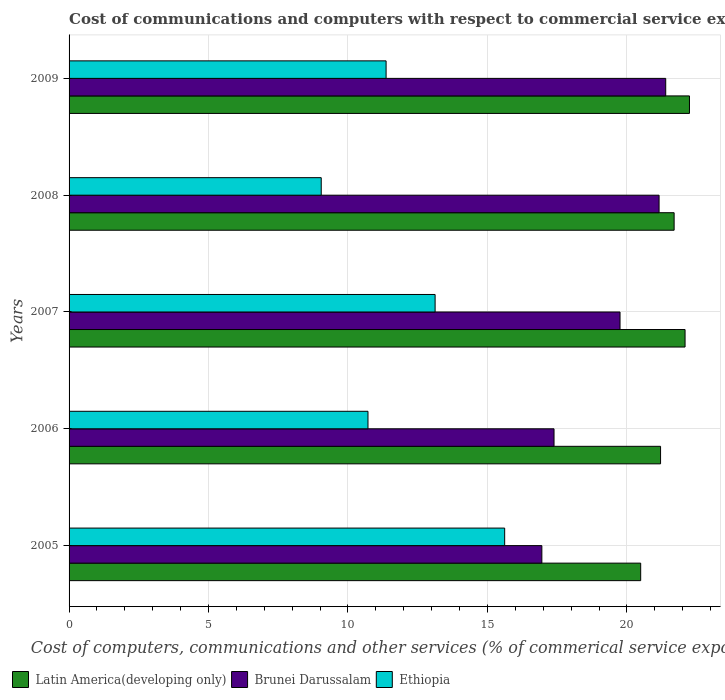How many different coloured bars are there?
Keep it short and to the point. 3. Are the number of bars per tick equal to the number of legend labels?
Offer a very short reply. Yes. How many bars are there on the 2nd tick from the bottom?
Offer a terse response. 3. What is the label of the 2nd group of bars from the top?
Give a very brief answer. 2008. In how many cases, is the number of bars for a given year not equal to the number of legend labels?
Offer a terse response. 0. What is the cost of communications and computers in Brunei Darussalam in 2005?
Keep it short and to the point. 16.95. Across all years, what is the maximum cost of communications and computers in Ethiopia?
Keep it short and to the point. 15.62. Across all years, what is the minimum cost of communications and computers in Ethiopia?
Provide a succinct answer. 9.04. In which year was the cost of communications and computers in Brunei Darussalam minimum?
Your response must be concise. 2005. What is the total cost of communications and computers in Ethiopia in the graph?
Your answer should be very brief. 59.86. What is the difference between the cost of communications and computers in Ethiopia in 2007 and that in 2009?
Give a very brief answer. 1.76. What is the difference between the cost of communications and computers in Brunei Darussalam in 2009 and the cost of communications and computers in Ethiopia in 2008?
Provide a succinct answer. 12.35. What is the average cost of communications and computers in Brunei Darussalam per year?
Provide a short and direct response. 19.33. In the year 2006, what is the difference between the cost of communications and computers in Latin America(developing only) and cost of communications and computers in Ethiopia?
Offer a very short reply. 10.49. In how many years, is the cost of communications and computers in Brunei Darussalam greater than 19 %?
Give a very brief answer. 3. What is the ratio of the cost of communications and computers in Latin America(developing only) in 2006 to that in 2008?
Your response must be concise. 0.98. Is the cost of communications and computers in Latin America(developing only) in 2006 less than that in 2008?
Your response must be concise. Yes. What is the difference between the highest and the second highest cost of communications and computers in Ethiopia?
Your answer should be compact. 2.49. What is the difference between the highest and the lowest cost of communications and computers in Latin America(developing only)?
Make the answer very short. 1.75. What does the 2nd bar from the top in 2008 represents?
Offer a very short reply. Brunei Darussalam. What does the 1st bar from the bottom in 2006 represents?
Offer a terse response. Latin America(developing only). How many years are there in the graph?
Your answer should be very brief. 5. Does the graph contain grids?
Offer a terse response. Yes. Where does the legend appear in the graph?
Ensure brevity in your answer.  Bottom left. How many legend labels are there?
Give a very brief answer. 3. How are the legend labels stacked?
Provide a succinct answer. Horizontal. What is the title of the graph?
Make the answer very short. Cost of communications and computers with respect to commercial service exports. Does "Congo (Democratic)" appear as one of the legend labels in the graph?
Provide a short and direct response. No. What is the label or title of the X-axis?
Make the answer very short. Cost of computers, communications and other services (% of commerical service exports). What is the label or title of the Y-axis?
Offer a very short reply. Years. What is the Cost of computers, communications and other services (% of commerical service exports) in Latin America(developing only) in 2005?
Keep it short and to the point. 20.49. What is the Cost of computers, communications and other services (% of commerical service exports) in Brunei Darussalam in 2005?
Make the answer very short. 16.95. What is the Cost of computers, communications and other services (% of commerical service exports) of Ethiopia in 2005?
Your response must be concise. 15.62. What is the Cost of computers, communications and other services (% of commerical service exports) in Latin America(developing only) in 2006?
Make the answer very short. 21.21. What is the Cost of computers, communications and other services (% of commerical service exports) in Brunei Darussalam in 2006?
Keep it short and to the point. 17.39. What is the Cost of computers, communications and other services (% of commerical service exports) of Ethiopia in 2006?
Keep it short and to the point. 10.72. What is the Cost of computers, communications and other services (% of commerical service exports) of Latin America(developing only) in 2007?
Your answer should be very brief. 22.09. What is the Cost of computers, communications and other services (% of commerical service exports) in Brunei Darussalam in 2007?
Provide a short and direct response. 19.75. What is the Cost of computers, communications and other services (% of commerical service exports) of Ethiopia in 2007?
Offer a terse response. 13.12. What is the Cost of computers, communications and other services (% of commerical service exports) in Latin America(developing only) in 2008?
Provide a succinct answer. 21.69. What is the Cost of computers, communications and other services (% of commerical service exports) in Brunei Darussalam in 2008?
Your response must be concise. 21.15. What is the Cost of computers, communications and other services (% of commerical service exports) of Ethiopia in 2008?
Your answer should be very brief. 9.04. What is the Cost of computers, communications and other services (% of commerical service exports) in Latin America(developing only) in 2009?
Give a very brief answer. 22.24. What is the Cost of computers, communications and other services (% of commerical service exports) in Brunei Darussalam in 2009?
Offer a terse response. 21.39. What is the Cost of computers, communications and other services (% of commerical service exports) in Ethiopia in 2009?
Your answer should be very brief. 11.37. Across all years, what is the maximum Cost of computers, communications and other services (% of commerical service exports) in Latin America(developing only)?
Ensure brevity in your answer.  22.24. Across all years, what is the maximum Cost of computers, communications and other services (% of commerical service exports) in Brunei Darussalam?
Your answer should be compact. 21.39. Across all years, what is the maximum Cost of computers, communications and other services (% of commerical service exports) in Ethiopia?
Make the answer very short. 15.62. Across all years, what is the minimum Cost of computers, communications and other services (% of commerical service exports) in Latin America(developing only)?
Ensure brevity in your answer.  20.49. Across all years, what is the minimum Cost of computers, communications and other services (% of commerical service exports) of Brunei Darussalam?
Give a very brief answer. 16.95. Across all years, what is the minimum Cost of computers, communications and other services (% of commerical service exports) in Ethiopia?
Provide a succinct answer. 9.04. What is the total Cost of computers, communications and other services (% of commerical service exports) of Latin America(developing only) in the graph?
Keep it short and to the point. 107.72. What is the total Cost of computers, communications and other services (% of commerical service exports) of Brunei Darussalam in the graph?
Your answer should be very brief. 96.64. What is the total Cost of computers, communications and other services (% of commerical service exports) of Ethiopia in the graph?
Keep it short and to the point. 59.86. What is the difference between the Cost of computers, communications and other services (% of commerical service exports) in Latin America(developing only) in 2005 and that in 2006?
Offer a terse response. -0.71. What is the difference between the Cost of computers, communications and other services (% of commerical service exports) of Brunei Darussalam in 2005 and that in 2006?
Make the answer very short. -0.44. What is the difference between the Cost of computers, communications and other services (% of commerical service exports) in Ethiopia in 2005 and that in 2006?
Your answer should be very brief. 4.9. What is the difference between the Cost of computers, communications and other services (% of commerical service exports) in Latin America(developing only) in 2005 and that in 2007?
Provide a succinct answer. -1.59. What is the difference between the Cost of computers, communications and other services (% of commerical service exports) in Brunei Darussalam in 2005 and that in 2007?
Make the answer very short. -2.8. What is the difference between the Cost of computers, communications and other services (% of commerical service exports) of Ethiopia in 2005 and that in 2007?
Your answer should be compact. 2.49. What is the difference between the Cost of computers, communications and other services (% of commerical service exports) of Latin America(developing only) in 2005 and that in 2008?
Ensure brevity in your answer.  -1.2. What is the difference between the Cost of computers, communications and other services (% of commerical service exports) of Brunei Darussalam in 2005 and that in 2008?
Offer a terse response. -4.2. What is the difference between the Cost of computers, communications and other services (% of commerical service exports) of Ethiopia in 2005 and that in 2008?
Give a very brief answer. 6.58. What is the difference between the Cost of computers, communications and other services (% of commerical service exports) of Latin America(developing only) in 2005 and that in 2009?
Make the answer very short. -1.75. What is the difference between the Cost of computers, communications and other services (% of commerical service exports) of Brunei Darussalam in 2005 and that in 2009?
Ensure brevity in your answer.  -4.44. What is the difference between the Cost of computers, communications and other services (% of commerical service exports) of Ethiopia in 2005 and that in 2009?
Your answer should be very brief. 4.25. What is the difference between the Cost of computers, communications and other services (% of commerical service exports) of Latin America(developing only) in 2006 and that in 2007?
Make the answer very short. -0.88. What is the difference between the Cost of computers, communications and other services (% of commerical service exports) in Brunei Darussalam in 2006 and that in 2007?
Your answer should be very brief. -2.37. What is the difference between the Cost of computers, communications and other services (% of commerical service exports) in Ethiopia in 2006 and that in 2007?
Ensure brevity in your answer.  -2.41. What is the difference between the Cost of computers, communications and other services (% of commerical service exports) of Latin America(developing only) in 2006 and that in 2008?
Your answer should be compact. -0.49. What is the difference between the Cost of computers, communications and other services (% of commerical service exports) in Brunei Darussalam in 2006 and that in 2008?
Your answer should be very brief. -3.77. What is the difference between the Cost of computers, communications and other services (% of commerical service exports) of Ethiopia in 2006 and that in 2008?
Your answer should be very brief. 1.68. What is the difference between the Cost of computers, communications and other services (% of commerical service exports) of Latin America(developing only) in 2006 and that in 2009?
Your response must be concise. -1.04. What is the difference between the Cost of computers, communications and other services (% of commerical service exports) of Brunei Darussalam in 2006 and that in 2009?
Provide a succinct answer. -4. What is the difference between the Cost of computers, communications and other services (% of commerical service exports) of Ethiopia in 2006 and that in 2009?
Your response must be concise. -0.65. What is the difference between the Cost of computers, communications and other services (% of commerical service exports) of Latin America(developing only) in 2007 and that in 2008?
Make the answer very short. 0.39. What is the difference between the Cost of computers, communications and other services (% of commerical service exports) of Brunei Darussalam in 2007 and that in 2008?
Provide a succinct answer. -1.4. What is the difference between the Cost of computers, communications and other services (% of commerical service exports) in Ethiopia in 2007 and that in 2008?
Keep it short and to the point. 4.08. What is the difference between the Cost of computers, communications and other services (% of commerical service exports) of Latin America(developing only) in 2007 and that in 2009?
Your answer should be compact. -0.16. What is the difference between the Cost of computers, communications and other services (% of commerical service exports) of Brunei Darussalam in 2007 and that in 2009?
Give a very brief answer. -1.64. What is the difference between the Cost of computers, communications and other services (% of commerical service exports) of Ethiopia in 2007 and that in 2009?
Offer a terse response. 1.76. What is the difference between the Cost of computers, communications and other services (% of commerical service exports) in Latin America(developing only) in 2008 and that in 2009?
Offer a very short reply. -0.55. What is the difference between the Cost of computers, communications and other services (% of commerical service exports) in Brunei Darussalam in 2008 and that in 2009?
Your answer should be very brief. -0.24. What is the difference between the Cost of computers, communications and other services (% of commerical service exports) of Ethiopia in 2008 and that in 2009?
Provide a short and direct response. -2.33. What is the difference between the Cost of computers, communications and other services (% of commerical service exports) of Latin America(developing only) in 2005 and the Cost of computers, communications and other services (% of commerical service exports) of Brunei Darussalam in 2006?
Make the answer very short. 3.11. What is the difference between the Cost of computers, communications and other services (% of commerical service exports) in Latin America(developing only) in 2005 and the Cost of computers, communications and other services (% of commerical service exports) in Ethiopia in 2006?
Your answer should be very brief. 9.78. What is the difference between the Cost of computers, communications and other services (% of commerical service exports) of Brunei Darussalam in 2005 and the Cost of computers, communications and other services (% of commerical service exports) of Ethiopia in 2006?
Your answer should be very brief. 6.23. What is the difference between the Cost of computers, communications and other services (% of commerical service exports) of Latin America(developing only) in 2005 and the Cost of computers, communications and other services (% of commerical service exports) of Brunei Darussalam in 2007?
Your answer should be compact. 0.74. What is the difference between the Cost of computers, communications and other services (% of commerical service exports) of Latin America(developing only) in 2005 and the Cost of computers, communications and other services (% of commerical service exports) of Ethiopia in 2007?
Provide a succinct answer. 7.37. What is the difference between the Cost of computers, communications and other services (% of commerical service exports) in Brunei Darussalam in 2005 and the Cost of computers, communications and other services (% of commerical service exports) in Ethiopia in 2007?
Provide a short and direct response. 3.83. What is the difference between the Cost of computers, communications and other services (% of commerical service exports) of Latin America(developing only) in 2005 and the Cost of computers, communications and other services (% of commerical service exports) of Brunei Darussalam in 2008?
Your answer should be compact. -0.66. What is the difference between the Cost of computers, communications and other services (% of commerical service exports) of Latin America(developing only) in 2005 and the Cost of computers, communications and other services (% of commerical service exports) of Ethiopia in 2008?
Ensure brevity in your answer.  11.45. What is the difference between the Cost of computers, communications and other services (% of commerical service exports) of Brunei Darussalam in 2005 and the Cost of computers, communications and other services (% of commerical service exports) of Ethiopia in 2008?
Give a very brief answer. 7.91. What is the difference between the Cost of computers, communications and other services (% of commerical service exports) of Latin America(developing only) in 2005 and the Cost of computers, communications and other services (% of commerical service exports) of Brunei Darussalam in 2009?
Provide a short and direct response. -0.9. What is the difference between the Cost of computers, communications and other services (% of commerical service exports) in Latin America(developing only) in 2005 and the Cost of computers, communications and other services (% of commerical service exports) in Ethiopia in 2009?
Give a very brief answer. 9.13. What is the difference between the Cost of computers, communications and other services (% of commerical service exports) in Brunei Darussalam in 2005 and the Cost of computers, communications and other services (% of commerical service exports) in Ethiopia in 2009?
Keep it short and to the point. 5.58. What is the difference between the Cost of computers, communications and other services (% of commerical service exports) in Latin America(developing only) in 2006 and the Cost of computers, communications and other services (% of commerical service exports) in Brunei Darussalam in 2007?
Your answer should be very brief. 1.45. What is the difference between the Cost of computers, communications and other services (% of commerical service exports) of Latin America(developing only) in 2006 and the Cost of computers, communications and other services (% of commerical service exports) of Ethiopia in 2007?
Your answer should be very brief. 8.08. What is the difference between the Cost of computers, communications and other services (% of commerical service exports) in Brunei Darussalam in 2006 and the Cost of computers, communications and other services (% of commerical service exports) in Ethiopia in 2007?
Ensure brevity in your answer.  4.26. What is the difference between the Cost of computers, communications and other services (% of commerical service exports) of Latin America(developing only) in 2006 and the Cost of computers, communications and other services (% of commerical service exports) of Brunei Darussalam in 2008?
Give a very brief answer. 0.05. What is the difference between the Cost of computers, communications and other services (% of commerical service exports) of Latin America(developing only) in 2006 and the Cost of computers, communications and other services (% of commerical service exports) of Ethiopia in 2008?
Give a very brief answer. 12.17. What is the difference between the Cost of computers, communications and other services (% of commerical service exports) in Brunei Darussalam in 2006 and the Cost of computers, communications and other services (% of commerical service exports) in Ethiopia in 2008?
Make the answer very short. 8.35. What is the difference between the Cost of computers, communications and other services (% of commerical service exports) in Latin America(developing only) in 2006 and the Cost of computers, communications and other services (% of commerical service exports) in Brunei Darussalam in 2009?
Make the answer very short. -0.18. What is the difference between the Cost of computers, communications and other services (% of commerical service exports) in Latin America(developing only) in 2006 and the Cost of computers, communications and other services (% of commerical service exports) in Ethiopia in 2009?
Your answer should be very brief. 9.84. What is the difference between the Cost of computers, communications and other services (% of commerical service exports) in Brunei Darussalam in 2006 and the Cost of computers, communications and other services (% of commerical service exports) in Ethiopia in 2009?
Your response must be concise. 6.02. What is the difference between the Cost of computers, communications and other services (% of commerical service exports) in Latin America(developing only) in 2007 and the Cost of computers, communications and other services (% of commerical service exports) in Brunei Darussalam in 2008?
Give a very brief answer. 0.93. What is the difference between the Cost of computers, communications and other services (% of commerical service exports) of Latin America(developing only) in 2007 and the Cost of computers, communications and other services (% of commerical service exports) of Ethiopia in 2008?
Ensure brevity in your answer.  13.04. What is the difference between the Cost of computers, communications and other services (% of commerical service exports) of Brunei Darussalam in 2007 and the Cost of computers, communications and other services (% of commerical service exports) of Ethiopia in 2008?
Your answer should be very brief. 10.71. What is the difference between the Cost of computers, communications and other services (% of commerical service exports) of Latin America(developing only) in 2007 and the Cost of computers, communications and other services (% of commerical service exports) of Brunei Darussalam in 2009?
Keep it short and to the point. 0.69. What is the difference between the Cost of computers, communications and other services (% of commerical service exports) of Latin America(developing only) in 2007 and the Cost of computers, communications and other services (% of commerical service exports) of Ethiopia in 2009?
Your response must be concise. 10.72. What is the difference between the Cost of computers, communications and other services (% of commerical service exports) in Brunei Darussalam in 2007 and the Cost of computers, communications and other services (% of commerical service exports) in Ethiopia in 2009?
Your answer should be compact. 8.39. What is the difference between the Cost of computers, communications and other services (% of commerical service exports) of Latin America(developing only) in 2008 and the Cost of computers, communications and other services (% of commerical service exports) of Brunei Darussalam in 2009?
Offer a terse response. 0.3. What is the difference between the Cost of computers, communications and other services (% of commerical service exports) in Latin America(developing only) in 2008 and the Cost of computers, communications and other services (% of commerical service exports) in Ethiopia in 2009?
Make the answer very short. 10.33. What is the difference between the Cost of computers, communications and other services (% of commerical service exports) in Brunei Darussalam in 2008 and the Cost of computers, communications and other services (% of commerical service exports) in Ethiopia in 2009?
Provide a succinct answer. 9.79. What is the average Cost of computers, communications and other services (% of commerical service exports) of Latin America(developing only) per year?
Provide a short and direct response. 21.54. What is the average Cost of computers, communications and other services (% of commerical service exports) in Brunei Darussalam per year?
Provide a short and direct response. 19.33. What is the average Cost of computers, communications and other services (% of commerical service exports) of Ethiopia per year?
Make the answer very short. 11.97. In the year 2005, what is the difference between the Cost of computers, communications and other services (% of commerical service exports) in Latin America(developing only) and Cost of computers, communications and other services (% of commerical service exports) in Brunei Darussalam?
Your answer should be very brief. 3.54. In the year 2005, what is the difference between the Cost of computers, communications and other services (% of commerical service exports) of Latin America(developing only) and Cost of computers, communications and other services (% of commerical service exports) of Ethiopia?
Keep it short and to the point. 4.88. In the year 2006, what is the difference between the Cost of computers, communications and other services (% of commerical service exports) in Latin America(developing only) and Cost of computers, communications and other services (% of commerical service exports) in Brunei Darussalam?
Provide a short and direct response. 3.82. In the year 2006, what is the difference between the Cost of computers, communications and other services (% of commerical service exports) in Latin America(developing only) and Cost of computers, communications and other services (% of commerical service exports) in Ethiopia?
Provide a succinct answer. 10.49. In the year 2006, what is the difference between the Cost of computers, communications and other services (% of commerical service exports) in Brunei Darussalam and Cost of computers, communications and other services (% of commerical service exports) in Ethiopia?
Keep it short and to the point. 6.67. In the year 2007, what is the difference between the Cost of computers, communications and other services (% of commerical service exports) of Latin America(developing only) and Cost of computers, communications and other services (% of commerical service exports) of Brunei Darussalam?
Your answer should be compact. 2.33. In the year 2007, what is the difference between the Cost of computers, communications and other services (% of commerical service exports) in Latin America(developing only) and Cost of computers, communications and other services (% of commerical service exports) in Ethiopia?
Give a very brief answer. 8.96. In the year 2007, what is the difference between the Cost of computers, communications and other services (% of commerical service exports) in Brunei Darussalam and Cost of computers, communications and other services (% of commerical service exports) in Ethiopia?
Your answer should be compact. 6.63. In the year 2008, what is the difference between the Cost of computers, communications and other services (% of commerical service exports) of Latin America(developing only) and Cost of computers, communications and other services (% of commerical service exports) of Brunei Darussalam?
Give a very brief answer. 0.54. In the year 2008, what is the difference between the Cost of computers, communications and other services (% of commerical service exports) of Latin America(developing only) and Cost of computers, communications and other services (% of commerical service exports) of Ethiopia?
Offer a terse response. 12.65. In the year 2008, what is the difference between the Cost of computers, communications and other services (% of commerical service exports) in Brunei Darussalam and Cost of computers, communications and other services (% of commerical service exports) in Ethiopia?
Offer a very short reply. 12.11. In the year 2009, what is the difference between the Cost of computers, communications and other services (% of commerical service exports) of Latin America(developing only) and Cost of computers, communications and other services (% of commerical service exports) of Brunei Darussalam?
Ensure brevity in your answer.  0.85. In the year 2009, what is the difference between the Cost of computers, communications and other services (% of commerical service exports) of Latin America(developing only) and Cost of computers, communications and other services (% of commerical service exports) of Ethiopia?
Offer a very short reply. 10.88. In the year 2009, what is the difference between the Cost of computers, communications and other services (% of commerical service exports) in Brunei Darussalam and Cost of computers, communications and other services (% of commerical service exports) in Ethiopia?
Your answer should be very brief. 10.03. What is the ratio of the Cost of computers, communications and other services (% of commerical service exports) of Latin America(developing only) in 2005 to that in 2006?
Make the answer very short. 0.97. What is the ratio of the Cost of computers, communications and other services (% of commerical service exports) in Brunei Darussalam in 2005 to that in 2006?
Give a very brief answer. 0.97. What is the ratio of the Cost of computers, communications and other services (% of commerical service exports) of Ethiopia in 2005 to that in 2006?
Keep it short and to the point. 1.46. What is the ratio of the Cost of computers, communications and other services (% of commerical service exports) of Latin America(developing only) in 2005 to that in 2007?
Your answer should be compact. 0.93. What is the ratio of the Cost of computers, communications and other services (% of commerical service exports) of Brunei Darussalam in 2005 to that in 2007?
Keep it short and to the point. 0.86. What is the ratio of the Cost of computers, communications and other services (% of commerical service exports) of Ethiopia in 2005 to that in 2007?
Keep it short and to the point. 1.19. What is the ratio of the Cost of computers, communications and other services (% of commerical service exports) in Latin America(developing only) in 2005 to that in 2008?
Give a very brief answer. 0.94. What is the ratio of the Cost of computers, communications and other services (% of commerical service exports) of Brunei Darussalam in 2005 to that in 2008?
Your answer should be compact. 0.8. What is the ratio of the Cost of computers, communications and other services (% of commerical service exports) in Ethiopia in 2005 to that in 2008?
Provide a succinct answer. 1.73. What is the ratio of the Cost of computers, communications and other services (% of commerical service exports) of Latin America(developing only) in 2005 to that in 2009?
Ensure brevity in your answer.  0.92. What is the ratio of the Cost of computers, communications and other services (% of commerical service exports) in Brunei Darussalam in 2005 to that in 2009?
Offer a very short reply. 0.79. What is the ratio of the Cost of computers, communications and other services (% of commerical service exports) of Ethiopia in 2005 to that in 2009?
Ensure brevity in your answer.  1.37. What is the ratio of the Cost of computers, communications and other services (% of commerical service exports) in Latin America(developing only) in 2006 to that in 2007?
Make the answer very short. 0.96. What is the ratio of the Cost of computers, communications and other services (% of commerical service exports) of Brunei Darussalam in 2006 to that in 2007?
Offer a very short reply. 0.88. What is the ratio of the Cost of computers, communications and other services (% of commerical service exports) in Ethiopia in 2006 to that in 2007?
Provide a short and direct response. 0.82. What is the ratio of the Cost of computers, communications and other services (% of commerical service exports) of Latin America(developing only) in 2006 to that in 2008?
Your answer should be compact. 0.98. What is the ratio of the Cost of computers, communications and other services (% of commerical service exports) in Brunei Darussalam in 2006 to that in 2008?
Your response must be concise. 0.82. What is the ratio of the Cost of computers, communications and other services (% of commerical service exports) in Ethiopia in 2006 to that in 2008?
Provide a short and direct response. 1.19. What is the ratio of the Cost of computers, communications and other services (% of commerical service exports) of Latin America(developing only) in 2006 to that in 2009?
Your answer should be very brief. 0.95. What is the ratio of the Cost of computers, communications and other services (% of commerical service exports) in Brunei Darussalam in 2006 to that in 2009?
Provide a succinct answer. 0.81. What is the ratio of the Cost of computers, communications and other services (% of commerical service exports) in Ethiopia in 2006 to that in 2009?
Give a very brief answer. 0.94. What is the ratio of the Cost of computers, communications and other services (% of commerical service exports) of Latin America(developing only) in 2007 to that in 2008?
Offer a terse response. 1.02. What is the ratio of the Cost of computers, communications and other services (% of commerical service exports) in Brunei Darussalam in 2007 to that in 2008?
Give a very brief answer. 0.93. What is the ratio of the Cost of computers, communications and other services (% of commerical service exports) in Ethiopia in 2007 to that in 2008?
Your answer should be very brief. 1.45. What is the ratio of the Cost of computers, communications and other services (% of commerical service exports) of Latin America(developing only) in 2007 to that in 2009?
Provide a short and direct response. 0.99. What is the ratio of the Cost of computers, communications and other services (% of commerical service exports) of Brunei Darussalam in 2007 to that in 2009?
Provide a succinct answer. 0.92. What is the ratio of the Cost of computers, communications and other services (% of commerical service exports) of Ethiopia in 2007 to that in 2009?
Your response must be concise. 1.15. What is the ratio of the Cost of computers, communications and other services (% of commerical service exports) in Latin America(developing only) in 2008 to that in 2009?
Make the answer very short. 0.98. What is the ratio of the Cost of computers, communications and other services (% of commerical service exports) of Brunei Darussalam in 2008 to that in 2009?
Offer a terse response. 0.99. What is the ratio of the Cost of computers, communications and other services (% of commerical service exports) of Ethiopia in 2008 to that in 2009?
Give a very brief answer. 0.8. What is the difference between the highest and the second highest Cost of computers, communications and other services (% of commerical service exports) of Latin America(developing only)?
Offer a very short reply. 0.16. What is the difference between the highest and the second highest Cost of computers, communications and other services (% of commerical service exports) in Brunei Darussalam?
Make the answer very short. 0.24. What is the difference between the highest and the second highest Cost of computers, communications and other services (% of commerical service exports) in Ethiopia?
Your answer should be compact. 2.49. What is the difference between the highest and the lowest Cost of computers, communications and other services (% of commerical service exports) in Latin America(developing only)?
Offer a terse response. 1.75. What is the difference between the highest and the lowest Cost of computers, communications and other services (% of commerical service exports) of Brunei Darussalam?
Ensure brevity in your answer.  4.44. What is the difference between the highest and the lowest Cost of computers, communications and other services (% of commerical service exports) of Ethiopia?
Provide a succinct answer. 6.58. 